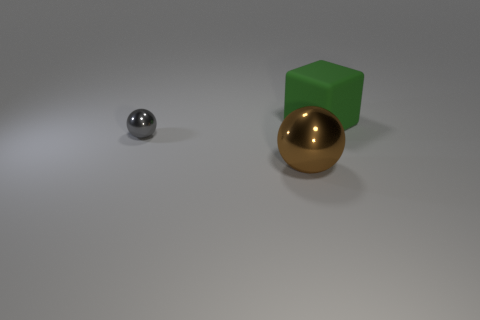Add 2 big yellow rubber cubes. How many objects exist? 5 Subtract all balls. How many objects are left? 1 Subtract all yellow blocks. Subtract all brown cylinders. How many blocks are left? 1 Subtract all gray cubes. How many gray balls are left? 1 Subtract all big yellow shiny balls. Subtract all gray metallic spheres. How many objects are left? 2 Add 3 big brown metallic spheres. How many big brown metallic spheres are left? 4 Add 1 brown cylinders. How many brown cylinders exist? 1 Subtract 0 yellow cylinders. How many objects are left? 3 Subtract 1 cubes. How many cubes are left? 0 